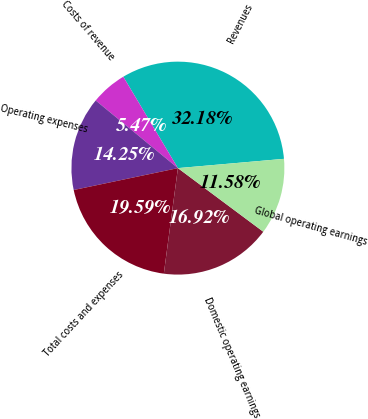Convert chart. <chart><loc_0><loc_0><loc_500><loc_500><pie_chart><fcel>Revenues<fcel>Costs of revenue<fcel>Operating expenses<fcel>Total costs and expenses<fcel>Domestic operating earnings<fcel>Global operating earnings<nl><fcel>32.18%<fcel>5.47%<fcel>14.25%<fcel>19.59%<fcel>16.92%<fcel>11.58%<nl></chart> 